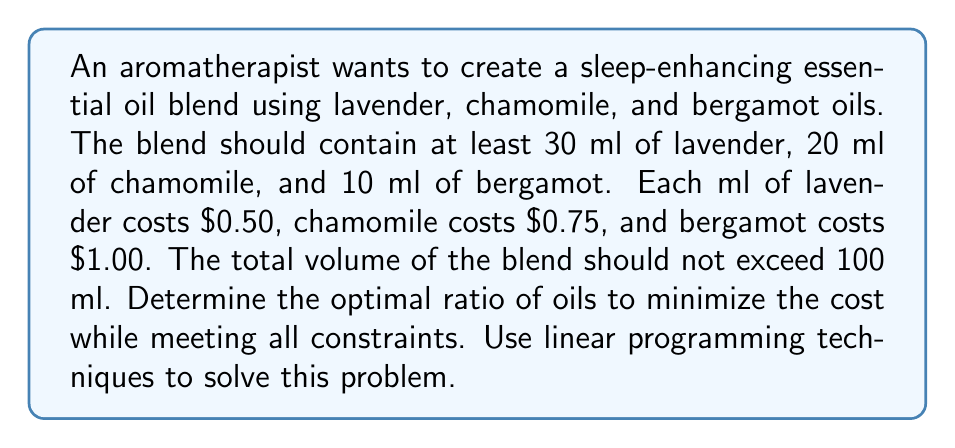Can you answer this question? Let's solve this problem using linear programming:

1. Define variables:
   $x$ = ml of lavender
   $y$ = ml of chamomile
   $z$ = ml of bergamot

2. Objective function (minimize cost):
   $\text{Minimize } C = 0.50x + 0.75y + 1.00z$

3. Constraints:
   $x \geq 30$ (lavender)
   $y \geq 20$ (chamomile)
   $z \geq 10$ (bergamot)
   $x + y + z \leq 100$ (total volume)

4. Set up the linear program:
   $$\begin{aligned}
   \text{Minimize: } & C = 0.50x + 0.75y + 1.00z \\
   \text{Subject to: } & x \geq 30 \\
   & y \geq 20 \\
   & z \geq 10 \\
   & x + y + z \leq 100 \\
   & x, y, z \geq 0
   \end{aligned}$$

5. Solve using the corner point method:
   The optimal solution will be at one of the corner points of the feasible region.

6. Corner points to consider:
   (30, 20, 10), (70, 20, 10), (30, 60, 10), (30, 20, 50)

7. Evaluate the objective function at each point:
   (30, 20, 10): $C = 0.50(30) + 0.75(20) + 1.00(10) = 40$
   (70, 20, 10): $C = 0.50(70) + 0.75(20) + 1.00(10) = 60$
   (30, 60, 10): $C = 0.50(30) + 0.75(60) + 1.00(10) = 70$
   (30, 20, 50): $C = 0.50(30) + 0.75(20) + 1.00(50) = 80$

8. The minimum cost occurs at (30, 20, 10), which gives the optimal ratio.

9. Calculate the ratio:
   Total volume = 30 + 20 + 10 = 60 ml
   Ratio = 30:20:10 = 3:2:1

Therefore, the optimal ratio of lavender:chamomile:bergamot is 3:2:1.
Answer: 3:2:1 (lavender:chamomile:bergamot) 